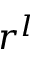Convert formula to latex. <formula><loc_0><loc_0><loc_500><loc_500>r ^ { l }</formula> 